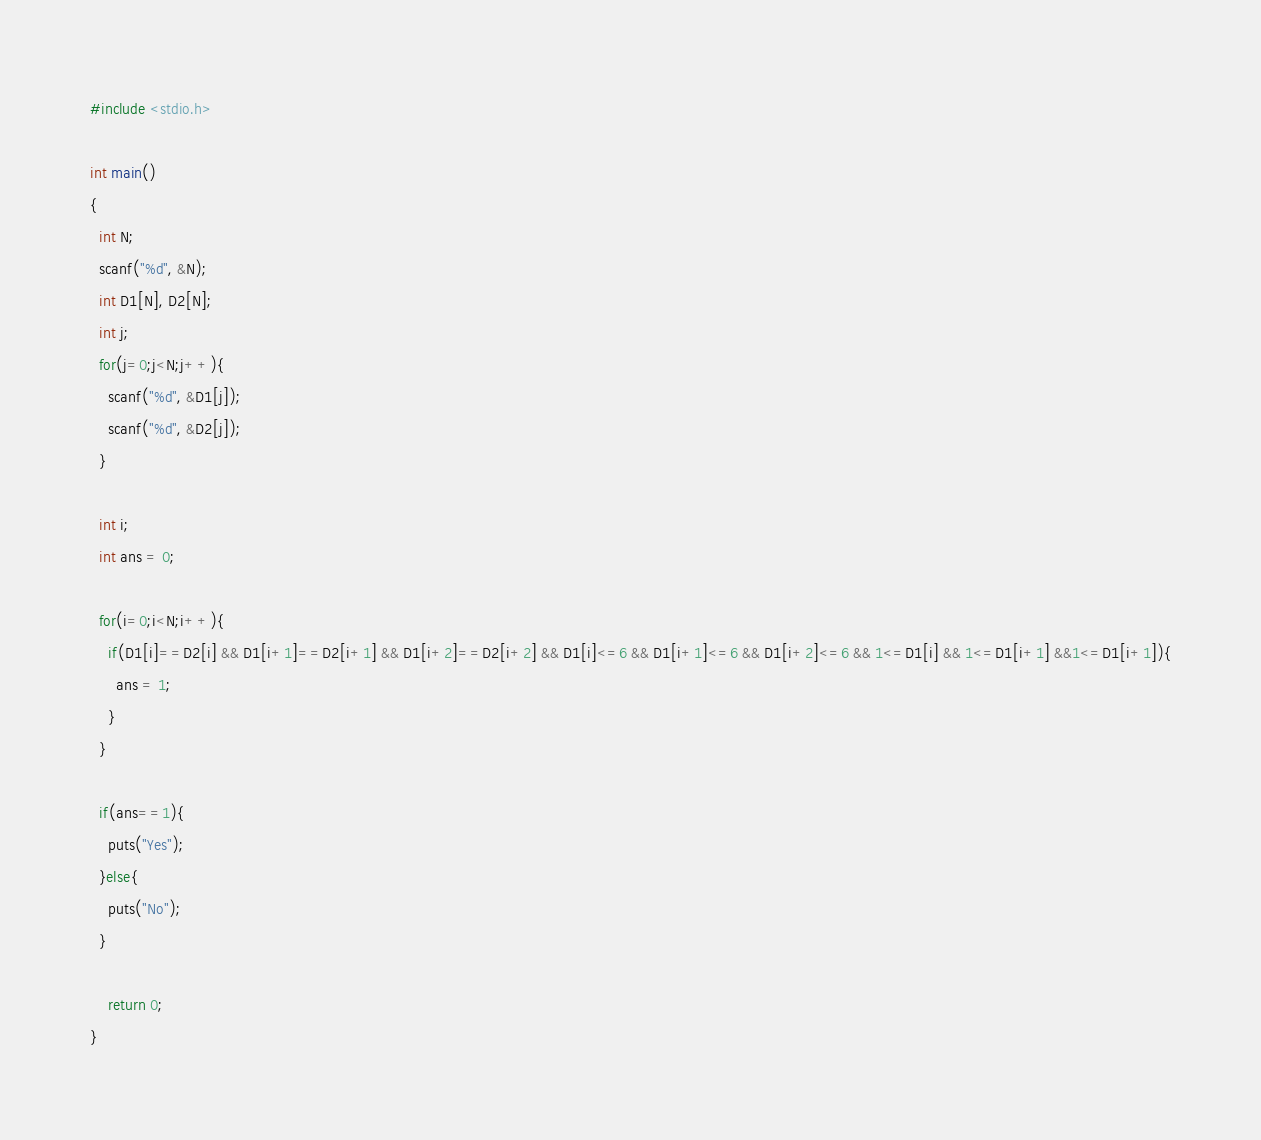Convert code to text. <code><loc_0><loc_0><loc_500><loc_500><_C_>#include <stdio.h>

int main()
{
  int N;
  scanf("%d", &N);
  int D1[N], D2[N];
  int j;
  for(j=0;j<N;j++){
    scanf("%d", &D1[j]);
    scanf("%d", &D2[j]);
  }

  int i;
  int ans = 0;

  for(i=0;i<N;i++){
    if(D1[i]==D2[i] && D1[i+1]==D2[i+1] && D1[i+2]==D2[i+2] && D1[i]<=6 && D1[i+1]<=6 && D1[i+2]<=6 && 1<=D1[i] && 1<=D1[i+1] &&1<=D1[i+1]){
      ans = 1;
    }
  }

  if(ans==1){
    puts("Yes");
  }else{
    puts("No");
  }

    return 0;
}</code> 